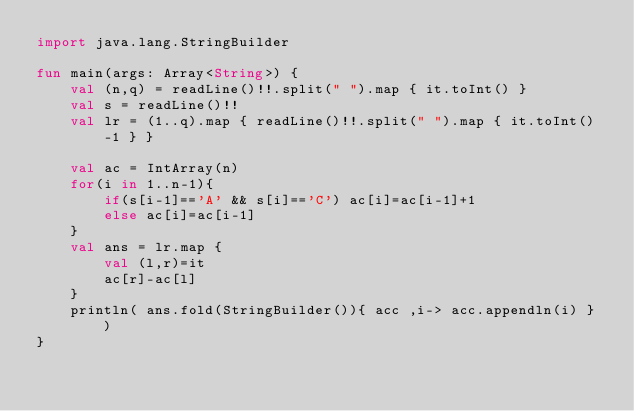<code> <loc_0><loc_0><loc_500><loc_500><_Kotlin_>import java.lang.StringBuilder

fun main(args: Array<String>) {
    val (n,q) = readLine()!!.split(" ").map { it.toInt() }
    val s = readLine()!!
    val lr = (1..q).map { readLine()!!.split(" ").map { it.toInt()-1 } }

    val ac = IntArray(n)
    for(i in 1..n-1){
        if(s[i-1]=='A' && s[i]=='C') ac[i]=ac[i-1]+1
        else ac[i]=ac[i-1]
    }
    val ans = lr.map {
        val (l,r)=it
        ac[r]-ac[l]
    }
    println( ans.fold(StringBuilder()){ acc ,i-> acc.appendln(i) } )
}

</code> 